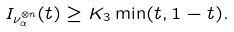<formula> <loc_0><loc_0><loc_500><loc_500>I _ { \nu _ { \alpha } ^ { \otimes n } } ( t ) \geq K _ { 3 } \min ( t , 1 - t ) .</formula> 